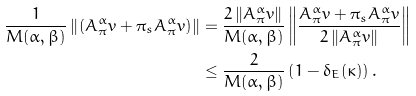Convert formula to latex. <formula><loc_0><loc_0><loc_500><loc_500>\frac { 1 } { M ( \alpha , \beta ) } \left \| \left ( A _ { \pi } ^ { \alpha } v + \pi _ { s } A _ { \pi } ^ { \alpha } v \right ) \right \| & = \frac { 2 \left \| A _ { \pi } ^ { \alpha } v \right \| } { M ( \alpha , \beta ) } \left \| \frac { A _ { \pi } ^ { \alpha } v + \pi _ { s } A _ { \pi } ^ { \alpha } v } { 2 \left \| A _ { \pi } ^ { \alpha } v \right \| } \right \| \\ & \leq \frac { 2 } { M ( \alpha , \beta ) } \left ( 1 - \delta _ { E } ( \kappa ) \right ) .</formula> 